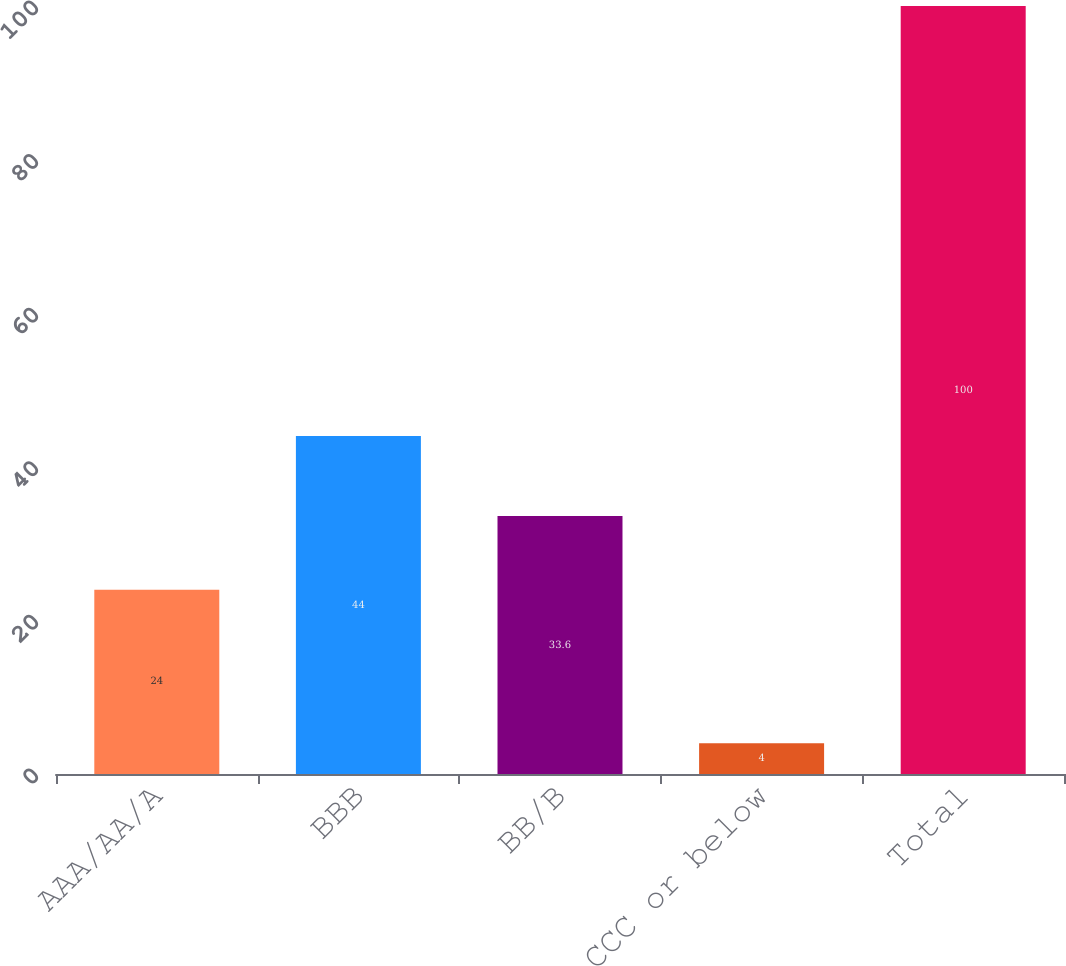Convert chart to OTSL. <chart><loc_0><loc_0><loc_500><loc_500><bar_chart><fcel>AAA/AA/A<fcel>BBB<fcel>BB/B<fcel>CCC or below<fcel>Total<nl><fcel>24<fcel>44<fcel>33.6<fcel>4<fcel>100<nl></chart> 